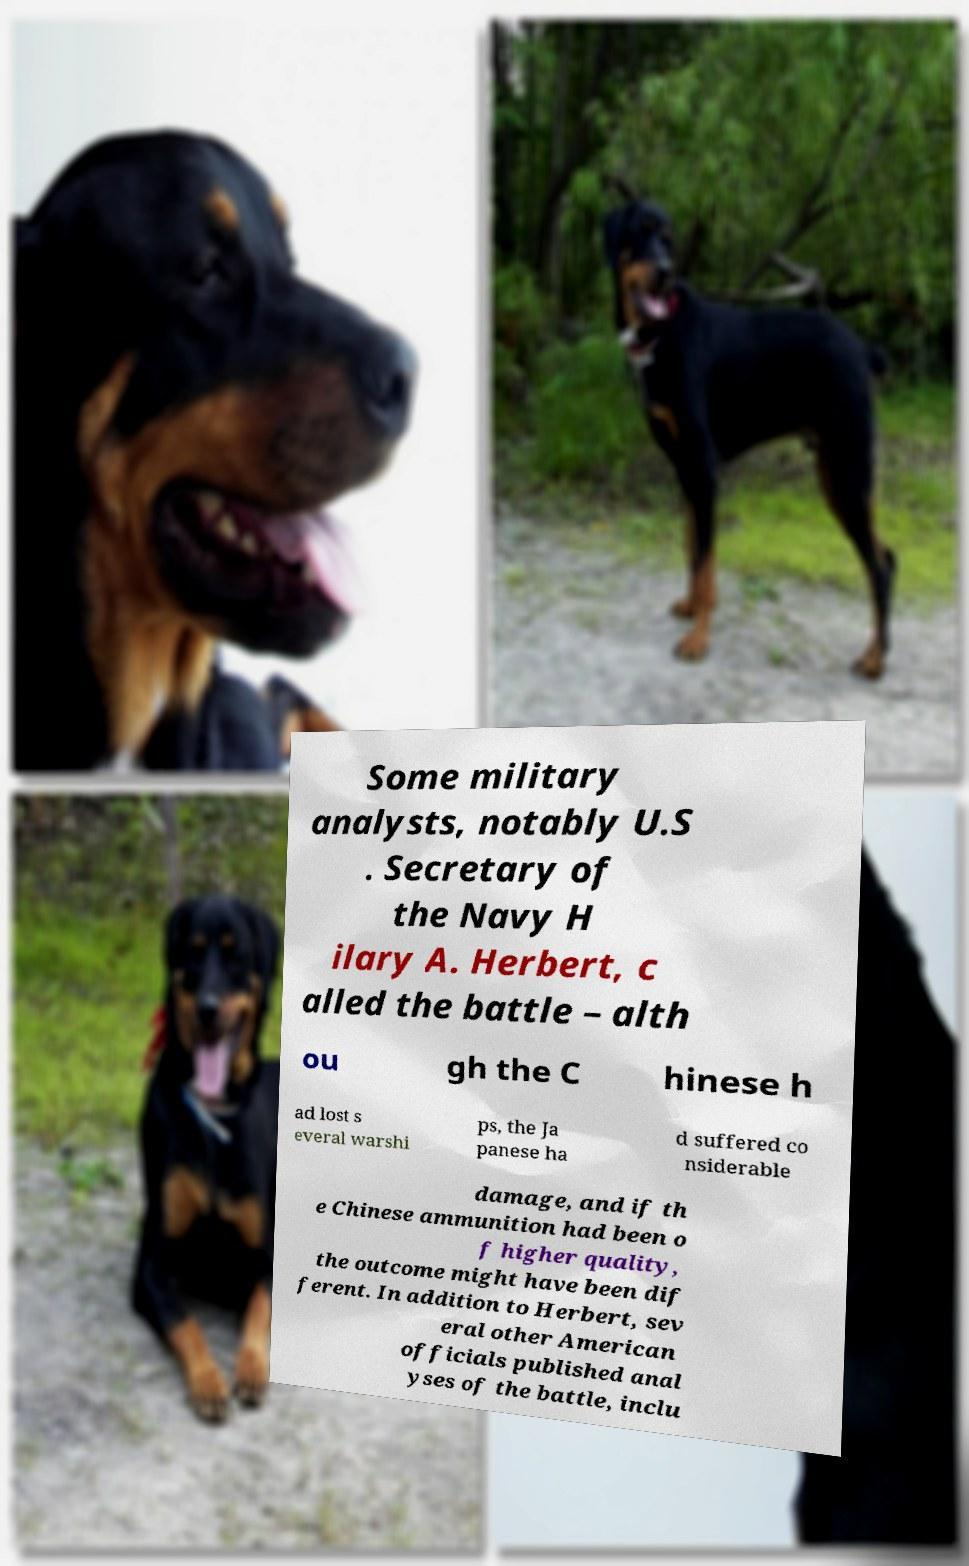Please read and relay the text visible in this image. What does it say? Some military analysts, notably U.S . Secretary of the Navy H ilary A. Herbert, c alled the battle – alth ou gh the C hinese h ad lost s everal warshi ps, the Ja panese ha d suffered co nsiderable damage, and if th e Chinese ammunition had been o f higher quality, the outcome might have been dif ferent. In addition to Herbert, sev eral other American officials published anal yses of the battle, inclu 